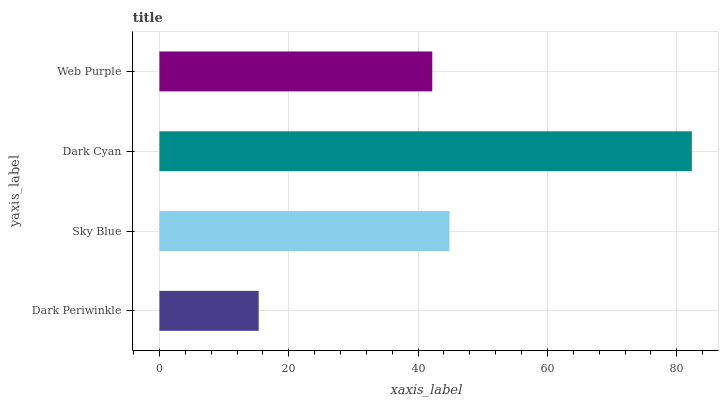Is Dark Periwinkle the minimum?
Answer yes or no. Yes. Is Dark Cyan the maximum?
Answer yes or no. Yes. Is Sky Blue the minimum?
Answer yes or no. No. Is Sky Blue the maximum?
Answer yes or no. No. Is Sky Blue greater than Dark Periwinkle?
Answer yes or no. Yes. Is Dark Periwinkle less than Sky Blue?
Answer yes or no. Yes. Is Dark Periwinkle greater than Sky Blue?
Answer yes or no. No. Is Sky Blue less than Dark Periwinkle?
Answer yes or no. No. Is Sky Blue the high median?
Answer yes or no. Yes. Is Web Purple the low median?
Answer yes or no. Yes. Is Web Purple the high median?
Answer yes or no. No. Is Sky Blue the low median?
Answer yes or no. No. 